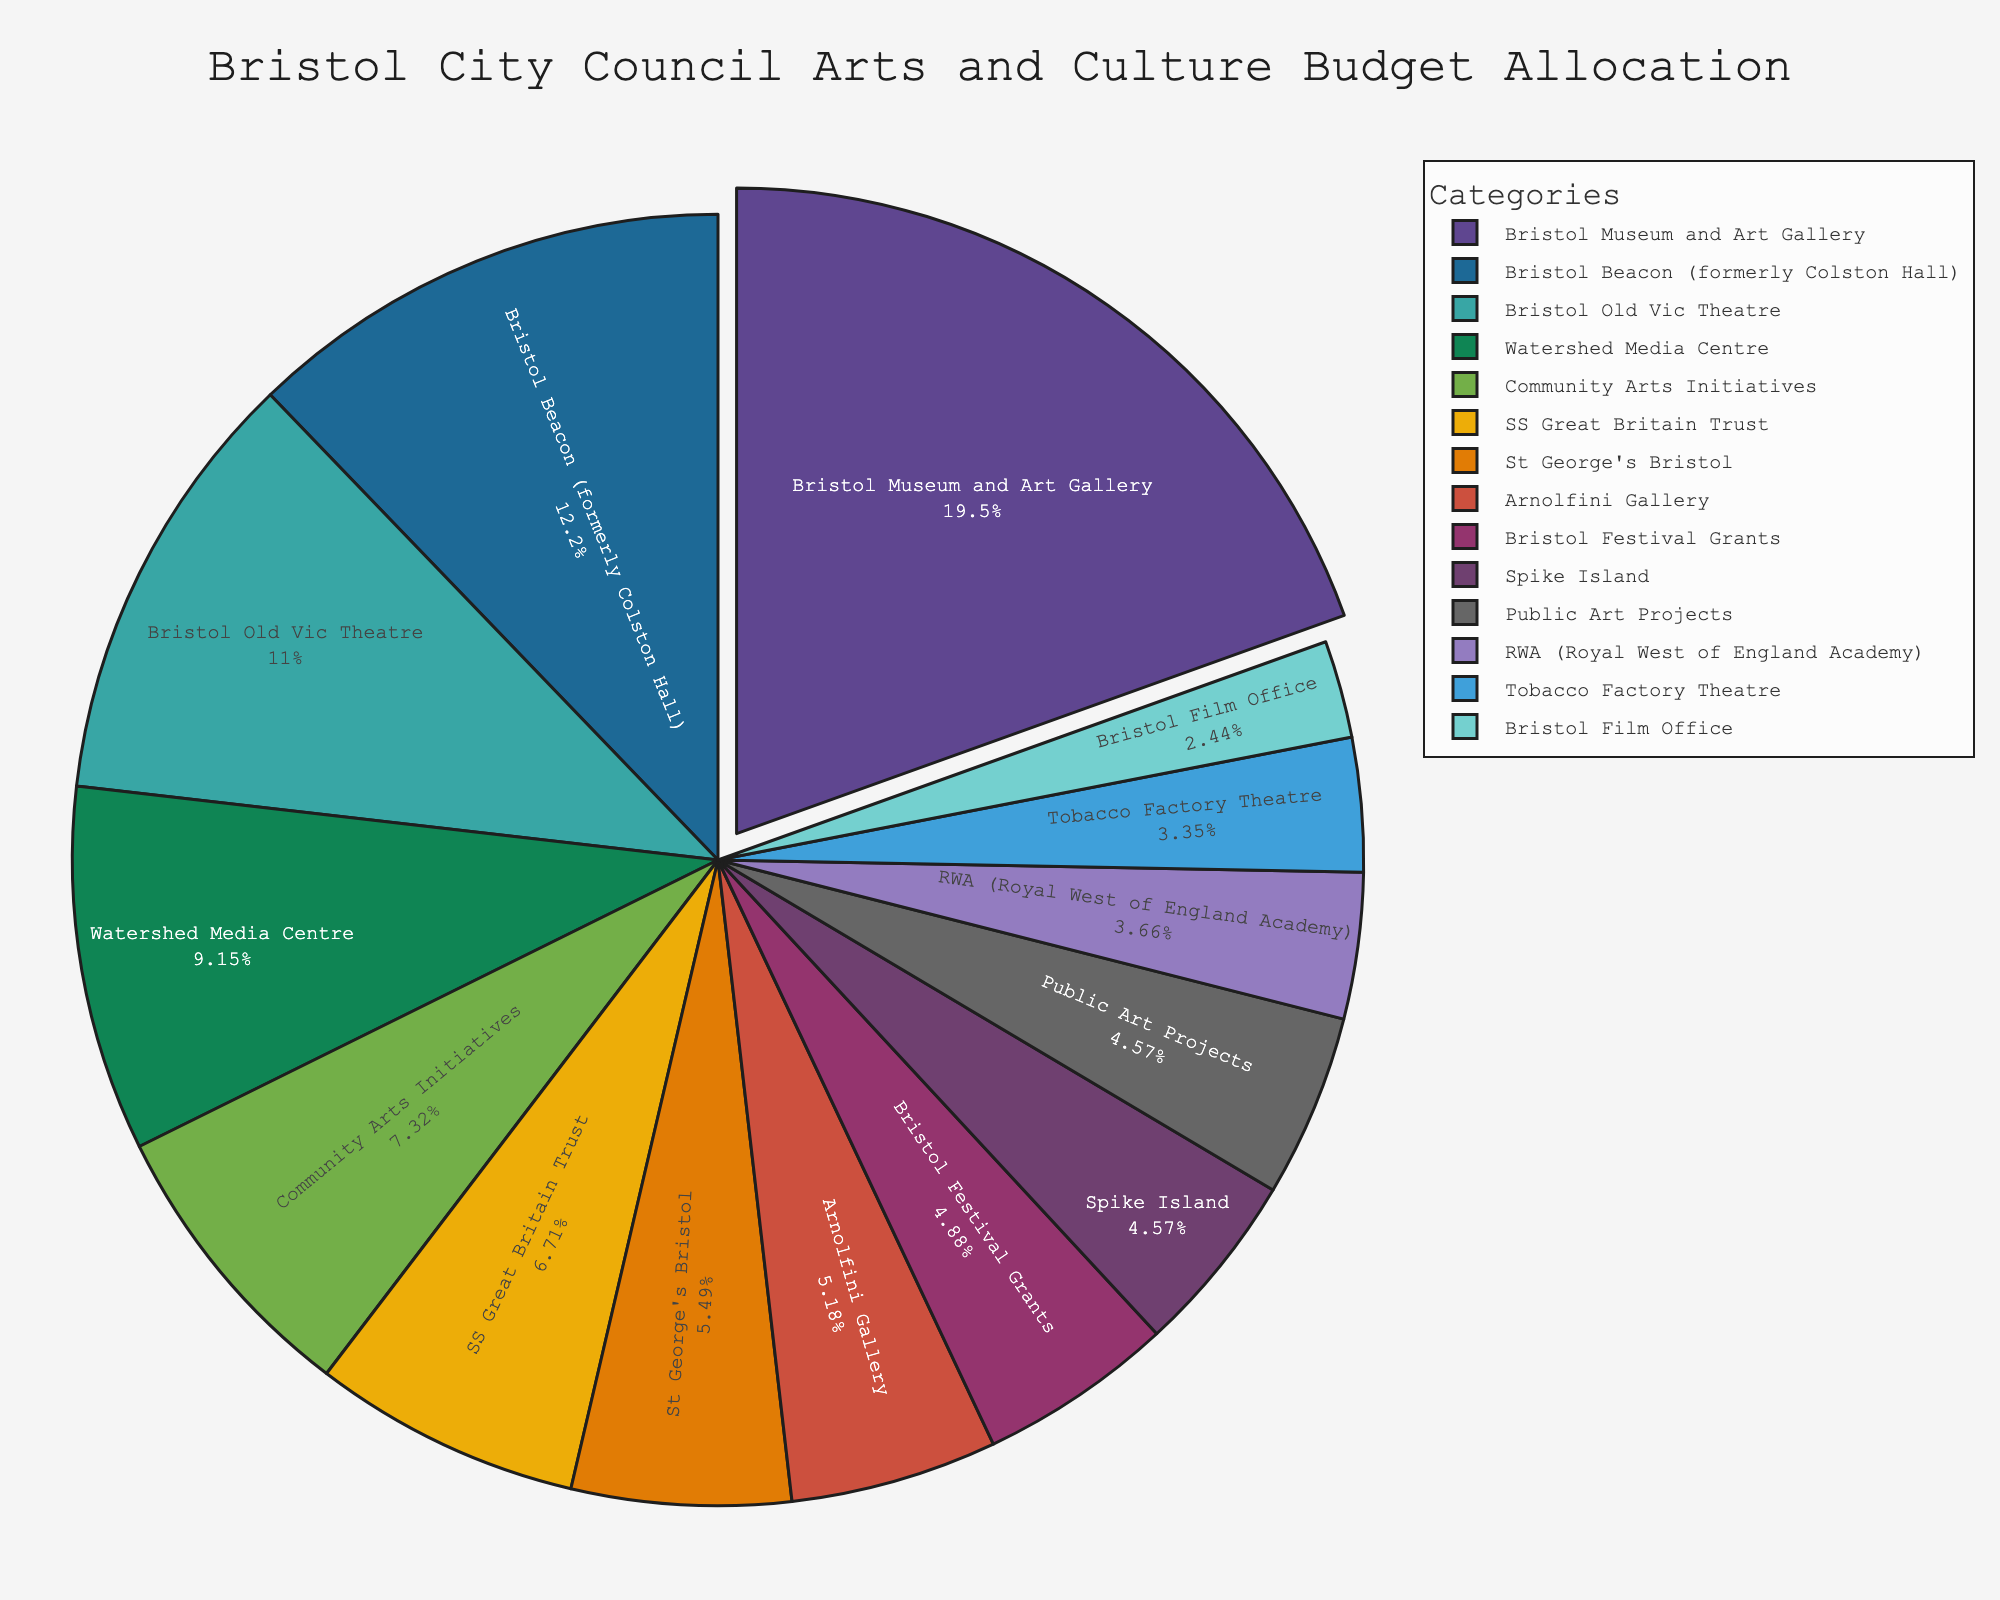Which category has the largest allocation? Identify the largest slice in the pie chart, which represents the category with the highest expenditure. The slice for "Bristol Museum and Art Gallery" is the largest.
Answer: Bristol Museum and Art Gallery What's the combined budget allocation for Bristol Old Vic Theatre and Watershed Media Centre? Find the slices for Bristol Old Vic Theatre (£1,800,000) and Watershed Media Centre (£1,500,000) and sum them up.
Answer: £3,300,000 Which category has a smaller budget allocation: Spike Island or Arnolfini Gallery? Compare the slices for Spike Island (£750,000) and Arnolfini Gallery (£850,000). Spike Island has a smaller budget.
Answer: Spike Island How many categories have a budget allocation greater than £1,000,000? Count the number of slices labeled with amounts greater than £1,000,000. They are "Bristol Museum and Art Gallery", "Bristol Old Vic Theatre", "Bristol Beacon (formerly Colston Hall)", "SS Great Britain Trust", "Community Arts Initiatives", and "Watershed Media Centre".
Answer: 6 What's the combined budget allocation for categories with allocations less than £750,000? Find all slices with allocations less than £750,000 and sum them up: RWA (£600,000), Tobacco Factory Theatre (£550,000), and Bristol Film Office (£400,000).
Answer: £1,550,000 Which categories have approximately the same budget allocation? Look for slices with similar sizes. For example, "Arnolfini Gallery" (£850,000) and "Bristol Festival Grants" (£800,000) are close.
Answer: Arnolfini Gallery and Bristol Festival Grants What is the average budget allocation of all the categories? Find the sum of all budget allocations and divide by the number of categories. Total budget = £14,100,000, number of categories = 14. The average allocation is £14,100,000 / 14.
Answer: £1,007,143 Is the budget allocation for Public Art Projects greater than that for St George's Bristol? Compare the slices for Public Art Projects (£750,000) and St George's Bristol (£900,000). St George's Bristol has a larger budget.
Answer: No Which category has the least budget allocation? Identify the smallest slice in the pie chart. The smallest slice represents "Tobacco Factory Theatre" with £550,000.
Answer: Tobacco Factory Theatre How does the budget allocation for SS Great Britain Trust compare to the total budget allocation for St George's Bristol and Arnolfini Gallery? Compare SS Great Britain Trust (£1,100,000) to the sum of St George's Bristol (£900,000) and Arnolfini Gallery (£850,000). SS Great Britain Trust has a smaller budget.
Answer: Smaller 